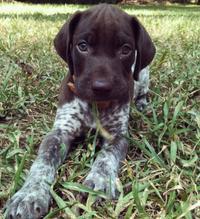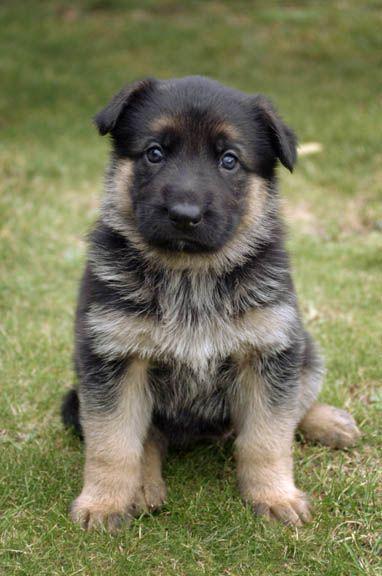The first image is the image on the left, the second image is the image on the right. Assess this claim about the two images: "All the dogs pictured are resting on the grassy ground.". Correct or not? Answer yes or no. Yes. 